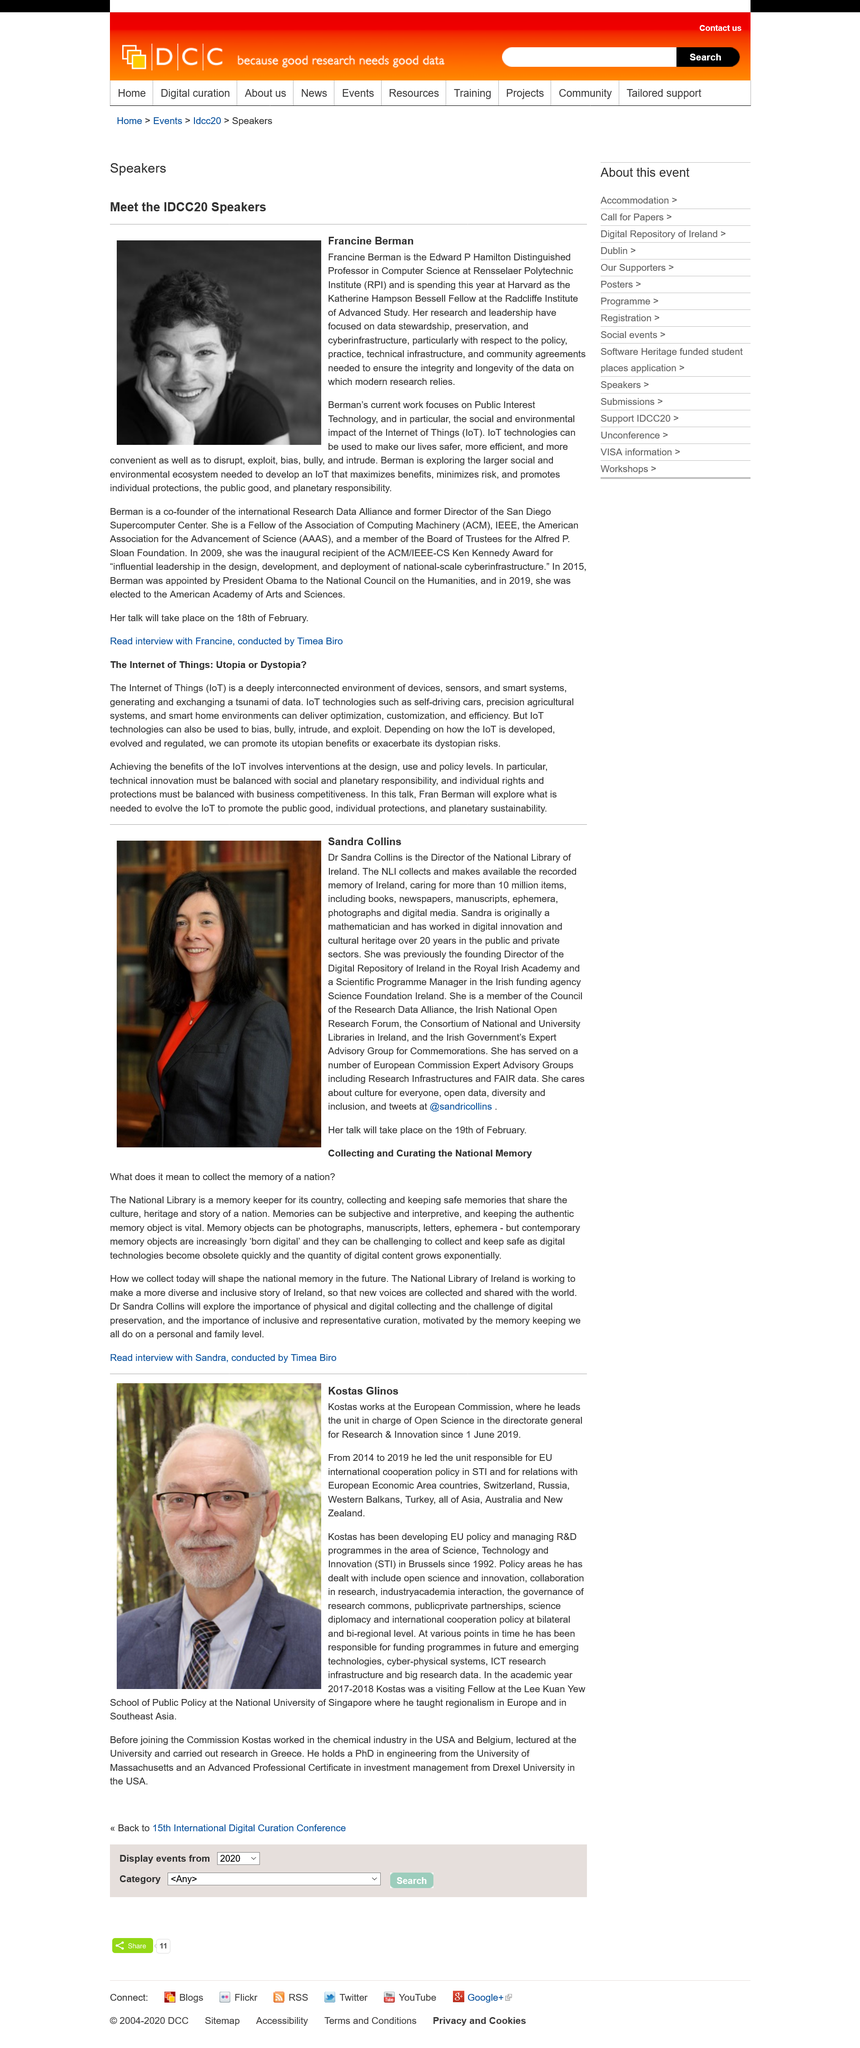Point out several critical features in this image. Francine Berman's current work focuses on public interest technology. Kostas Glinos, in his previous position, led the unit responsible for EU international cooperation policy in science, technology, and innovation, as well as relations with EEA countries, Switzerland, Russia, Western Balkans, Turkey, Asia, Australia, and New Zealand. The man in the photograph is Kostas Glinos, and his name is... Francine Berman is in the picture. Kostas Glinos works at the European Commission, leading the unit responsible for Open Science in the directorate general for Research & Innovation. 